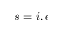<formula> <loc_0><loc_0><loc_500><loc_500>s = i , e</formula> 